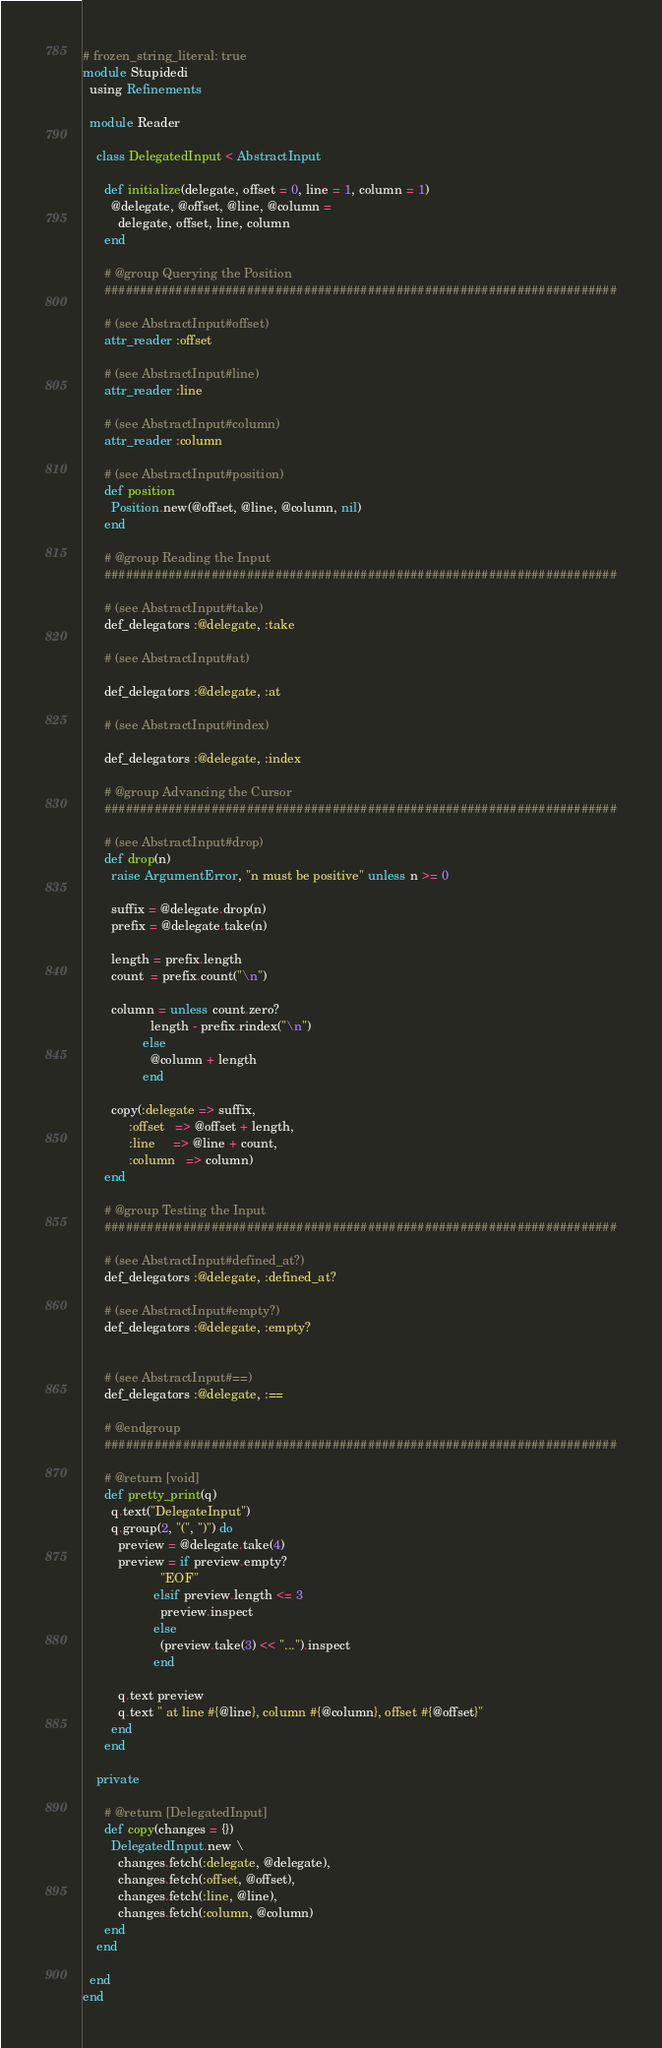Convert code to text. <code><loc_0><loc_0><loc_500><loc_500><_Ruby_># frozen_string_literal: true
module Stupidedi
  using Refinements

  module Reader

    class DelegatedInput < AbstractInput

      def initialize(delegate, offset = 0, line = 1, column = 1)
        @delegate, @offset, @line, @column =
          delegate, offset, line, column
      end

      # @group Querying the Position
      ########################################################################

      # (see AbstractInput#offset)
      attr_reader :offset

      # (see AbstractInput#line)
      attr_reader :line

      # (see AbstractInput#column)
      attr_reader :column

      # (see AbstractInput#position)
      def position
        Position.new(@offset, @line, @column, nil)
      end

      # @group Reading the Input
      ########################################################################

      # (see AbstractInput#take)
      def_delegators :@delegate, :take

      # (see AbstractInput#at)

      def_delegators :@delegate, :at

      # (see AbstractInput#index)

      def_delegators :@delegate, :index

      # @group Advancing the Cursor
      ########################################################################

      # (see AbstractInput#drop)
      def drop(n)
        raise ArgumentError, "n must be positive" unless n >= 0

        suffix = @delegate.drop(n)
        prefix = @delegate.take(n)

        length = prefix.length
        count  = prefix.count("\n")

        column = unless count.zero?
                   length - prefix.rindex("\n")
                 else
                   @column + length
                 end

        copy(:delegate => suffix,
             :offset   => @offset + length,
             :line     => @line + count,
             :column   => column)
      end

      # @group Testing the Input
      ########################################################################

      # (see AbstractInput#defined_at?)
      def_delegators :@delegate, :defined_at?

      # (see AbstractInput#empty?)
      def_delegators :@delegate, :empty?


      # (see AbstractInput#==)
      def_delegators :@delegate, :==

      # @endgroup
      ########################################################################

      # @return [void]
      def pretty_print(q)
        q.text("DelegateInput")
        q.group(2, "(", ")") do
          preview = @delegate.take(4)
          preview = if preview.empty?
                      "EOF"
                    elsif preview.length <= 3
                      preview.inspect
                    else
                      (preview.take(3) << "...").inspect
                    end

          q.text preview
          q.text " at line #{@line}, column #{@column}, offset #{@offset}"
        end
      end

    private

      # @return [DelegatedInput]
      def copy(changes = {})
        DelegatedInput.new \
          changes.fetch(:delegate, @delegate),
          changes.fetch(:offset, @offset),
          changes.fetch(:line, @line),
          changes.fetch(:column, @column)
      end
    end

  end
end
</code> 